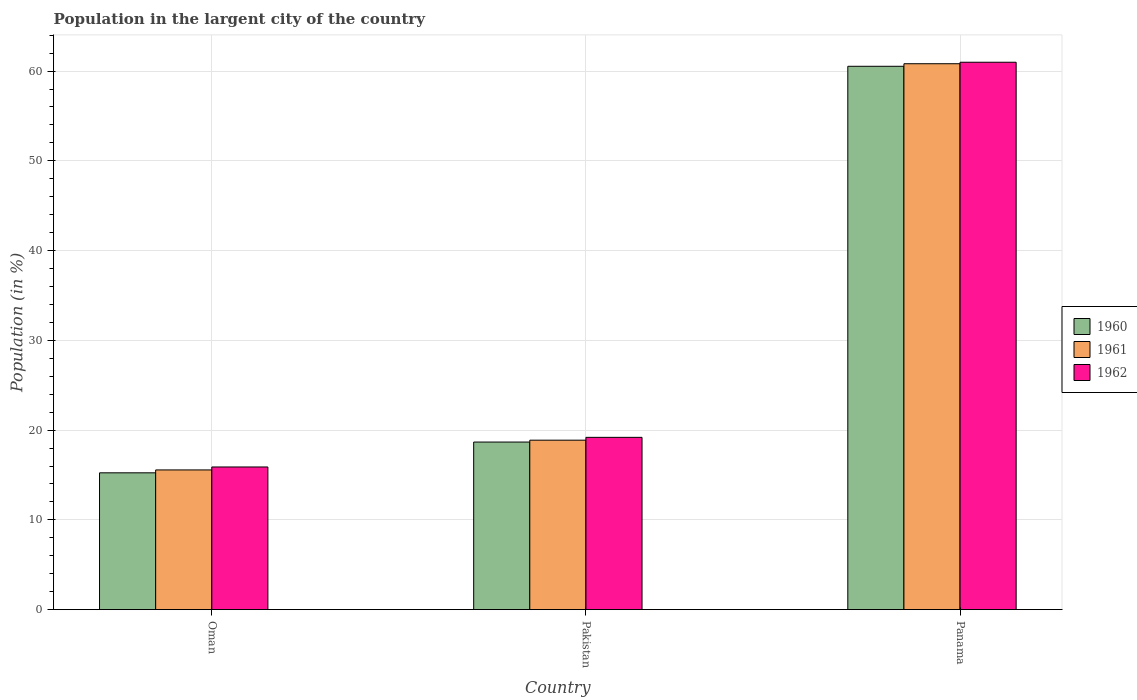How many different coloured bars are there?
Offer a very short reply. 3. Are the number of bars per tick equal to the number of legend labels?
Your answer should be compact. Yes. Are the number of bars on each tick of the X-axis equal?
Make the answer very short. Yes. What is the label of the 3rd group of bars from the left?
Keep it short and to the point. Panama. In how many cases, is the number of bars for a given country not equal to the number of legend labels?
Keep it short and to the point. 0. What is the percentage of population in the largent city in 1962 in Panama?
Provide a succinct answer. 60.99. Across all countries, what is the maximum percentage of population in the largent city in 1961?
Offer a very short reply. 60.82. Across all countries, what is the minimum percentage of population in the largent city in 1962?
Give a very brief answer. 15.89. In which country was the percentage of population in the largent city in 1962 maximum?
Offer a very short reply. Panama. In which country was the percentage of population in the largent city in 1962 minimum?
Ensure brevity in your answer.  Oman. What is the total percentage of population in the largent city in 1962 in the graph?
Give a very brief answer. 96.07. What is the difference between the percentage of population in the largent city in 1962 in Pakistan and that in Panama?
Your answer should be compact. -41.79. What is the difference between the percentage of population in the largent city in 1960 in Oman and the percentage of population in the largent city in 1962 in Pakistan?
Provide a succinct answer. -3.95. What is the average percentage of population in the largent city in 1960 per country?
Your response must be concise. 31.48. What is the difference between the percentage of population in the largent city of/in 1960 and percentage of population in the largent city of/in 1962 in Oman?
Your response must be concise. -0.65. In how many countries, is the percentage of population in the largent city in 1960 greater than 40 %?
Your answer should be compact. 1. What is the ratio of the percentage of population in the largent city in 1962 in Oman to that in Panama?
Give a very brief answer. 0.26. Is the percentage of population in the largent city in 1962 in Oman less than that in Pakistan?
Provide a short and direct response. Yes. Is the difference between the percentage of population in the largent city in 1960 in Pakistan and Panama greater than the difference between the percentage of population in the largent city in 1962 in Pakistan and Panama?
Offer a terse response. No. What is the difference between the highest and the second highest percentage of population in the largent city in 1961?
Make the answer very short. -41.94. What is the difference between the highest and the lowest percentage of population in the largent city in 1961?
Offer a terse response. 45.26. In how many countries, is the percentage of population in the largent city in 1961 greater than the average percentage of population in the largent city in 1961 taken over all countries?
Your response must be concise. 1. What does the 2nd bar from the left in Pakistan represents?
Your answer should be very brief. 1961. What does the 3rd bar from the right in Oman represents?
Your answer should be compact. 1960. How many bars are there?
Offer a terse response. 9. Are all the bars in the graph horizontal?
Ensure brevity in your answer.  No. Are the values on the major ticks of Y-axis written in scientific E-notation?
Offer a very short reply. No. Does the graph contain any zero values?
Provide a short and direct response. No. Where does the legend appear in the graph?
Provide a short and direct response. Center right. How are the legend labels stacked?
Keep it short and to the point. Vertical. What is the title of the graph?
Your answer should be very brief. Population in the largent city of the country. Does "1998" appear as one of the legend labels in the graph?
Your response must be concise. No. What is the label or title of the X-axis?
Your response must be concise. Country. What is the Population (in %) in 1960 in Oman?
Make the answer very short. 15.24. What is the Population (in %) of 1961 in Oman?
Offer a terse response. 15.56. What is the Population (in %) of 1962 in Oman?
Your answer should be compact. 15.89. What is the Population (in %) in 1960 in Pakistan?
Provide a short and direct response. 18.67. What is the Population (in %) of 1961 in Pakistan?
Your answer should be very brief. 18.88. What is the Population (in %) of 1962 in Pakistan?
Offer a very short reply. 19.19. What is the Population (in %) in 1960 in Panama?
Give a very brief answer. 60.54. What is the Population (in %) in 1961 in Panama?
Make the answer very short. 60.82. What is the Population (in %) in 1962 in Panama?
Offer a very short reply. 60.99. Across all countries, what is the maximum Population (in %) in 1960?
Offer a terse response. 60.54. Across all countries, what is the maximum Population (in %) of 1961?
Keep it short and to the point. 60.82. Across all countries, what is the maximum Population (in %) of 1962?
Your answer should be compact. 60.99. Across all countries, what is the minimum Population (in %) in 1960?
Offer a very short reply. 15.24. Across all countries, what is the minimum Population (in %) in 1961?
Ensure brevity in your answer.  15.56. Across all countries, what is the minimum Population (in %) of 1962?
Give a very brief answer. 15.89. What is the total Population (in %) of 1960 in the graph?
Your answer should be compact. 94.45. What is the total Population (in %) of 1961 in the graph?
Provide a succinct answer. 95.26. What is the total Population (in %) in 1962 in the graph?
Ensure brevity in your answer.  96.07. What is the difference between the Population (in %) in 1960 in Oman and that in Pakistan?
Offer a very short reply. -3.43. What is the difference between the Population (in %) of 1961 in Oman and that in Pakistan?
Provide a succinct answer. -3.32. What is the difference between the Population (in %) in 1962 in Oman and that in Pakistan?
Keep it short and to the point. -3.3. What is the difference between the Population (in %) of 1960 in Oman and that in Panama?
Your answer should be compact. -45.29. What is the difference between the Population (in %) of 1961 in Oman and that in Panama?
Offer a very short reply. -45.26. What is the difference between the Population (in %) of 1962 in Oman and that in Panama?
Your response must be concise. -45.09. What is the difference between the Population (in %) in 1960 in Pakistan and that in Panama?
Make the answer very short. -41.87. What is the difference between the Population (in %) of 1961 in Pakistan and that in Panama?
Provide a short and direct response. -41.94. What is the difference between the Population (in %) of 1962 in Pakistan and that in Panama?
Your response must be concise. -41.79. What is the difference between the Population (in %) of 1960 in Oman and the Population (in %) of 1961 in Pakistan?
Make the answer very short. -3.64. What is the difference between the Population (in %) of 1960 in Oman and the Population (in %) of 1962 in Pakistan?
Provide a succinct answer. -3.95. What is the difference between the Population (in %) of 1961 in Oman and the Population (in %) of 1962 in Pakistan?
Offer a very short reply. -3.63. What is the difference between the Population (in %) in 1960 in Oman and the Population (in %) in 1961 in Panama?
Your response must be concise. -45.58. What is the difference between the Population (in %) in 1960 in Oman and the Population (in %) in 1962 in Panama?
Give a very brief answer. -45.74. What is the difference between the Population (in %) of 1961 in Oman and the Population (in %) of 1962 in Panama?
Provide a succinct answer. -45.42. What is the difference between the Population (in %) of 1960 in Pakistan and the Population (in %) of 1961 in Panama?
Keep it short and to the point. -42.15. What is the difference between the Population (in %) of 1960 in Pakistan and the Population (in %) of 1962 in Panama?
Make the answer very short. -42.32. What is the difference between the Population (in %) in 1961 in Pakistan and the Population (in %) in 1962 in Panama?
Give a very brief answer. -42.11. What is the average Population (in %) in 1960 per country?
Make the answer very short. 31.48. What is the average Population (in %) in 1961 per country?
Your response must be concise. 31.75. What is the average Population (in %) in 1962 per country?
Provide a succinct answer. 32.02. What is the difference between the Population (in %) in 1960 and Population (in %) in 1961 in Oman?
Provide a short and direct response. -0.32. What is the difference between the Population (in %) of 1960 and Population (in %) of 1962 in Oman?
Your answer should be compact. -0.65. What is the difference between the Population (in %) of 1961 and Population (in %) of 1962 in Oman?
Your answer should be very brief. -0.33. What is the difference between the Population (in %) in 1960 and Population (in %) in 1961 in Pakistan?
Provide a succinct answer. -0.21. What is the difference between the Population (in %) in 1960 and Population (in %) in 1962 in Pakistan?
Offer a very short reply. -0.53. What is the difference between the Population (in %) of 1961 and Population (in %) of 1962 in Pakistan?
Keep it short and to the point. -0.32. What is the difference between the Population (in %) of 1960 and Population (in %) of 1961 in Panama?
Offer a very short reply. -0.28. What is the difference between the Population (in %) of 1960 and Population (in %) of 1962 in Panama?
Your answer should be very brief. -0.45. What is the difference between the Population (in %) of 1961 and Population (in %) of 1962 in Panama?
Offer a very short reply. -0.17. What is the ratio of the Population (in %) in 1960 in Oman to that in Pakistan?
Offer a very short reply. 0.82. What is the ratio of the Population (in %) in 1961 in Oman to that in Pakistan?
Provide a short and direct response. 0.82. What is the ratio of the Population (in %) of 1962 in Oman to that in Pakistan?
Provide a short and direct response. 0.83. What is the ratio of the Population (in %) in 1960 in Oman to that in Panama?
Your answer should be compact. 0.25. What is the ratio of the Population (in %) in 1961 in Oman to that in Panama?
Keep it short and to the point. 0.26. What is the ratio of the Population (in %) in 1962 in Oman to that in Panama?
Provide a succinct answer. 0.26. What is the ratio of the Population (in %) of 1960 in Pakistan to that in Panama?
Your answer should be very brief. 0.31. What is the ratio of the Population (in %) of 1961 in Pakistan to that in Panama?
Your response must be concise. 0.31. What is the ratio of the Population (in %) of 1962 in Pakistan to that in Panama?
Give a very brief answer. 0.31. What is the difference between the highest and the second highest Population (in %) of 1960?
Offer a very short reply. 41.87. What is the difference between the highest and the second highest Population (in %) of 1961?
Provide a short and direct response. 41.94. What is the difference between the highest and the second highest Population (in %) of 1962?
Offer a very short reply. 41.79. What is the difference between the highest and the lowest Population (in %) in 1960?
Your answer should be compact. 45.29. What is the difference between the highest and the lowest Population (in %) in 1961?
Give a very brief answer. 45.26. What is the difference between the highest and the lowest Population (in %) of 1962?
Ensure brevity in your answer.  45.09. 